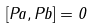<formula> <loc_0><loc_0><loc_500><loc_500>[ P a , P b ] = 0</formula> 